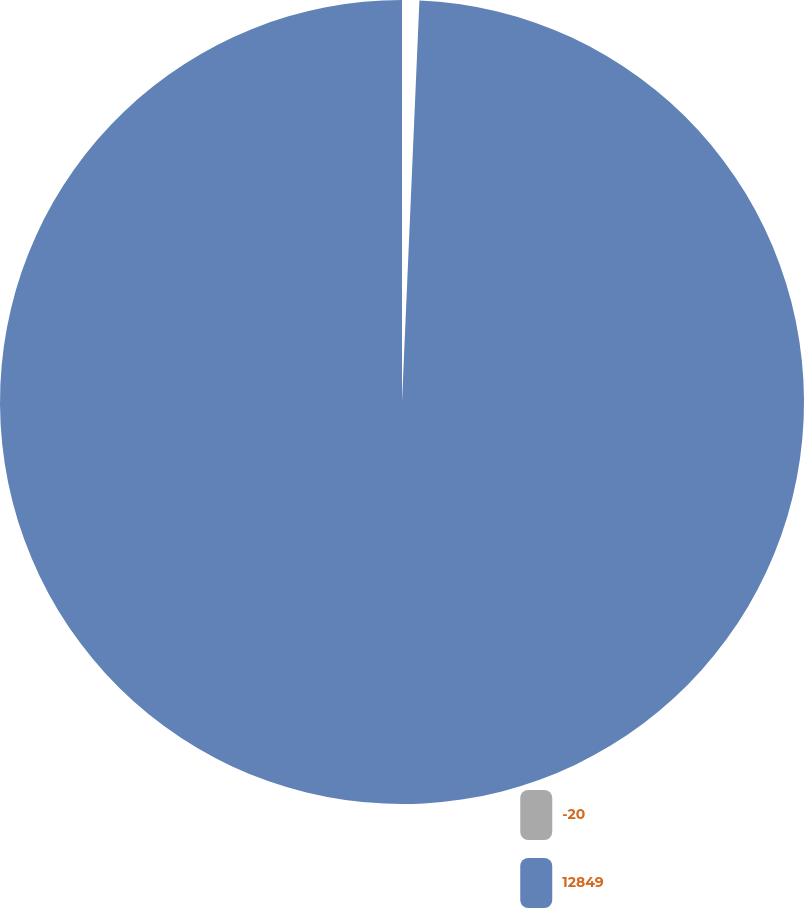Convert chart to OTSL. <chart><loc_0><loc_0><loc_500><loc_500><pie_chart><fcel>-20<fcel>12849<nl><fcel>0.69%<fcel>99.31%<nl></chart> 